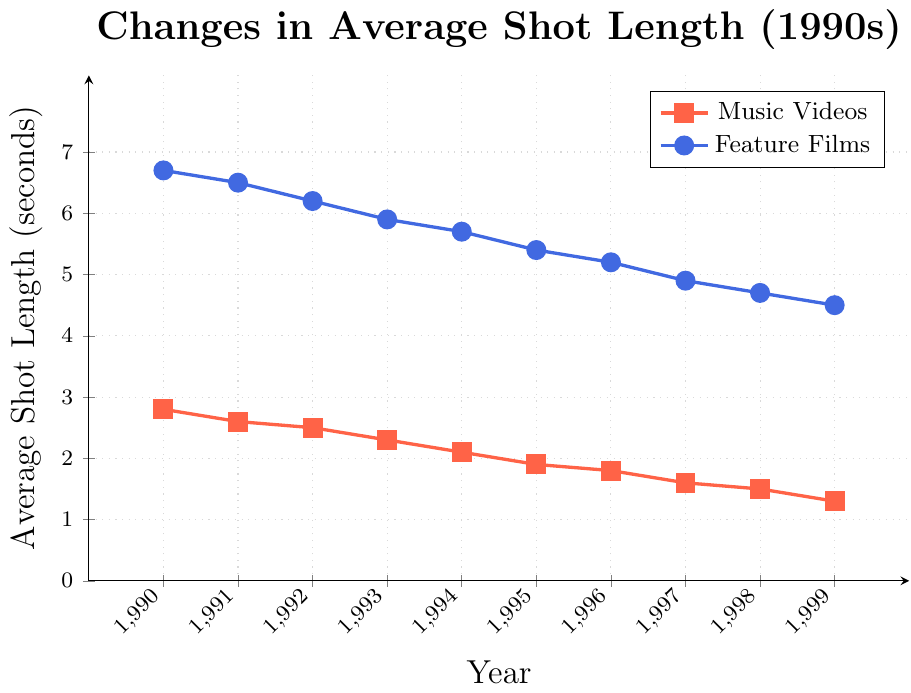What is the trend observed in the average shot length of music videos from 1990 to 1999? As depicted by the red line with square markers, the average shot length of music videos decreases each year from 2.8 seconds in 1990 to 1.3 seconds in 1999.
Answer: Decreasing trend Which year saw the highest average shot length in feature films? By viewing the blue line with circular markers, we see the highest average shot length in feature films occurs in 1990 at 6.7 seconds.
Answer: 1990 How much did the average shot length in feature films decrease from 1990 to 1999? The average shot length in feature films was 6.7 seconds in 1990 and decreased to 4.5 seconds in 1999. By subtracting 4.5 from 6.7, we find the decrease to be 2.2 seconds.
Answer: 2.2 seconds By how much did the average shot length in music videos decrease from 1994 to 1999? The average shot length in music videos in 1994 was 2.1 seconds and decreased to 1.3 seconds in 1999. Subtracting 1.3 from 2.1 gives a decrease of 0.8 seconds.
Answer: 0.8 seconds In which year was the difference between the average shot length in music videos and feature films the greatest? By comparing the vertical distances between the lines for each year, we see the greatest difference in 1990. The difference is 6.7 - 2.8 = 3.9 seconds.
Answer: 1990 On average, which had shorter shot lengths during the 1990s: music videos or feature films? Observing both trends from 1990 to 1999, the red line (music videos) is consistently below the blue line (feature films), indicating shorter shot lengths in music videos throughout the decade.
Answer: Music videos Which year saw the smallest difference between the average shot lengths in music videos and feature films? The smallest difference can be observed in 1999, where the average shot length in feature films is 4.5 seconds and in music videos is 1.3 seconds, yielding a difference of 4.5 - 1.3 = 3.2 seconds, which is the lowest observed value.
Answer: 1999 What is the average shot length across all years for both music videos and feature films combined? To get the combined average, first sum the averages for both categories over all years, then divide by the total number of years. The totals are (sum of music videos) 2.8 + 2.6 + 2.5 + 2.3 + 2.1 + 1.9 + 1.8 + 1.6 + 1.5 + 1.3 = 20.4 and (sum of feature films) 6.7 + 6.5 + 6.2 + 5.9 + 5.7 + 5.4 + 5.2 + 4.9 + 4.7 + 4.5 = 55.7. The overall total is 20.4 + 55.7 = 76.1 divided by 20 (2 categories for each of the 10 years), giving 76.1/20 = 3.805 seconds.
Answer: 3.805 seconds Between 1990 and 1995, by how much did the average shot length of music videos decrease? From 1990 to 1995, the average shot length in music videos went from 2.8 seconds to 1.9 seconds. The change is 2.8 - 1.9 = 0.9 seconds.
Answer: 0.9 seconds 